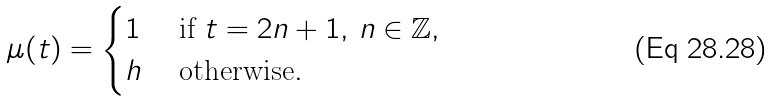Convert formula to latex. <formula><loc_0><loc_0><loc_500><loc_500>\mu ( t ) = \begin{cases} 1 & \text { if } t = 2 n + 1 , \, n \in \mathbb { Z } , \\ h & \text { otherwise} . \end{cases}</formula> 